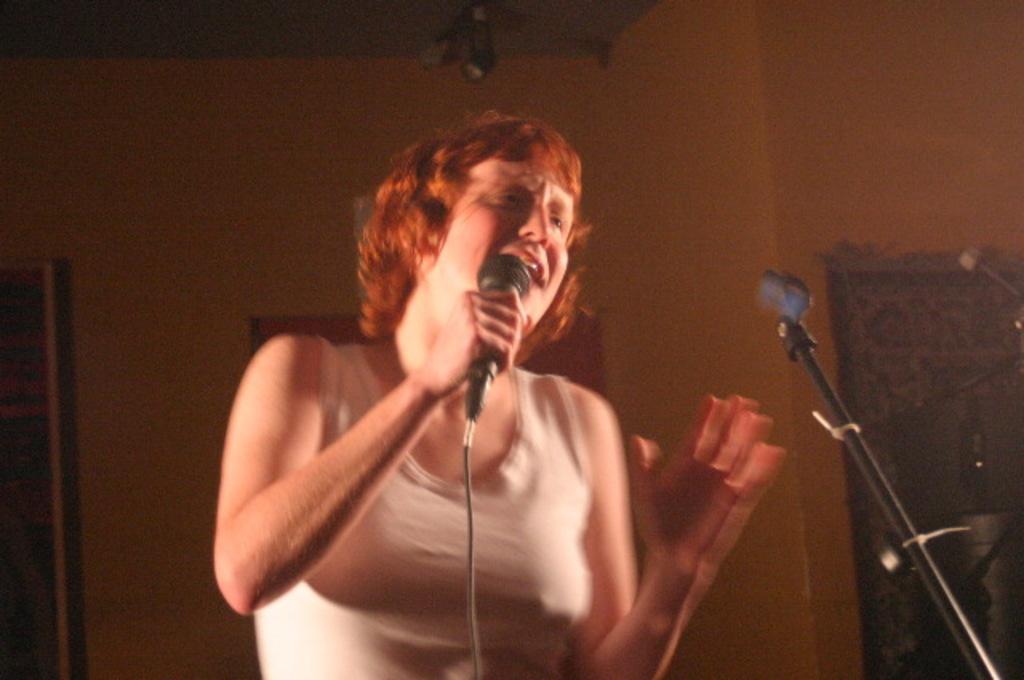Could you give a brief overview of what you see in this image? On the background we can see wall. Here we can see one woman standing in front of a mike stand and holding a mike in her hand and singing. Her hair colour is brown. 